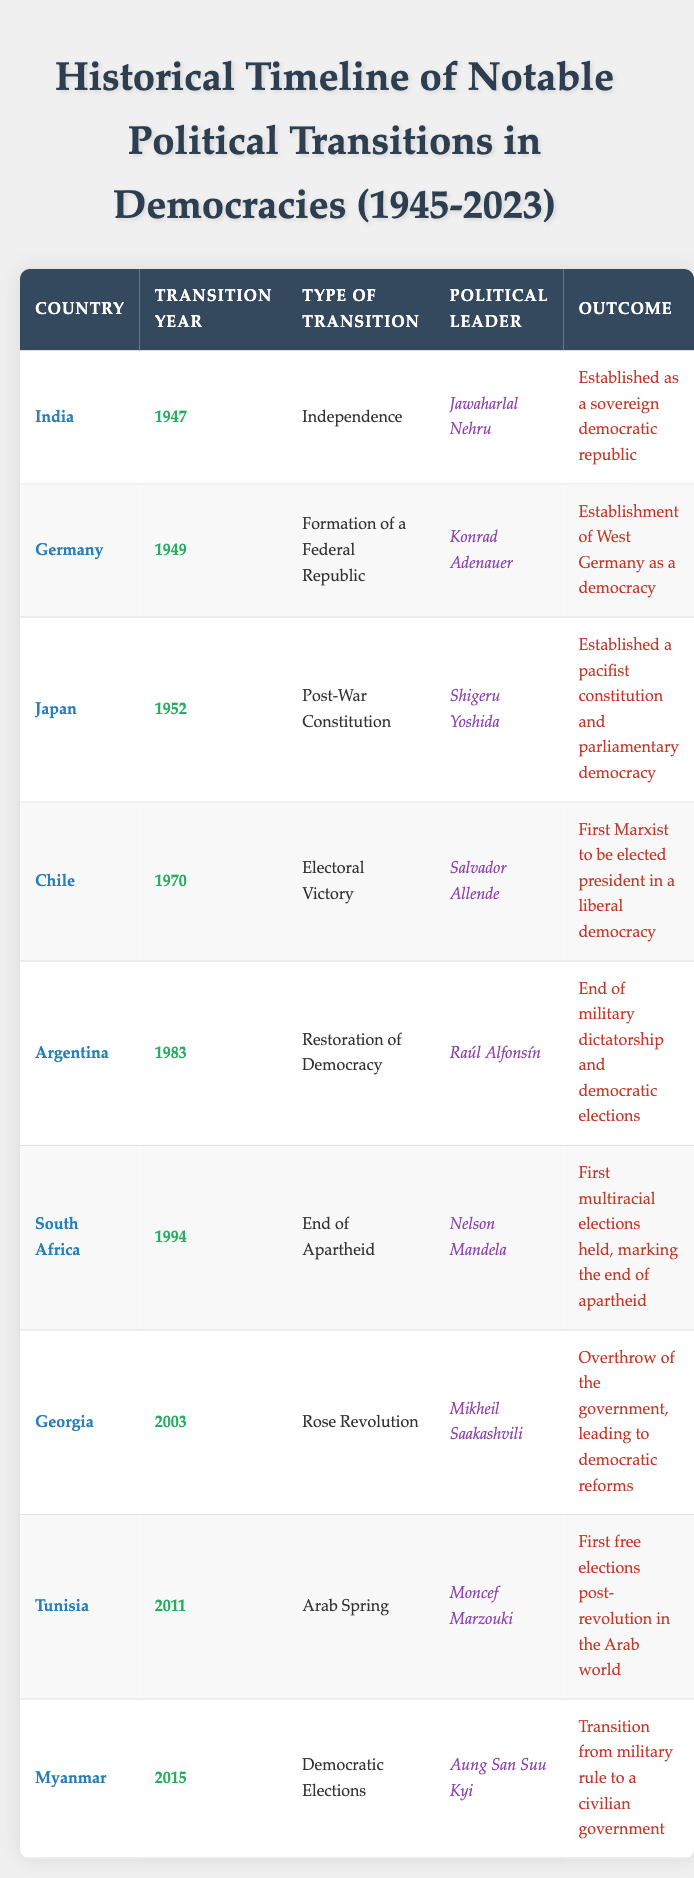What country experienced a transition year in 1983? By looking at the table, we can find the entry for the year 1983 and read the corresponding country. The entry states that Argentina had a transition in 1983.
Answer: Argentina Who was the political leader during Japan's transition in 1952? The table shows that in the row corresponding to Japan in the year 1952, the political leader listed is Shigeru Yoshida.
Answer: Shigeru Yoshida Did South Africa's transition in 1994 lead to a multiracial election? The table indicates that in 1994, South Africa's outcome was described as the first multiracial elections held, which confirms that the statement is true.
Answer: Yes How many transitions occurred between 1950 and 2000? To find this, we count the rows of transitions that fall within the specified range. The entries for 1952 (Japan), 1970 (Chile), 1983 (Argentina), and 1994 (South Africa) give us a total of 4 transitions during this period.
Answer: 4 Was there a political transition in Chile that involved the first Marxist president in a liberal democracy? Reviewing the table shows that in the year 1970 for Chile, the outcome specifies that Salvador Allende was the first Marxist elected as president in a liberal democracy. Therefore, the statement is true.
Answer: Yes What is the outcome of the Rose Revolution in Georgia? In the table, the entry for Georgia in 2003 states the outcome was the overthrow of the government, leading to democratic reforms. This is directly taken from the relevant row.
Answer: Overthrow of the government, leading to democratic reforms Which country achieved independence in 1947? By scanning through the table for the transition year of 1947, we find that the country listed is India.
Answer: India Identify the type of transition that led to the end of apartheid in South Africa. The row for South Africa in 1994 describes the type of transition as the end of apartheid, confirming the specific transition type.
Answer: End of Apartheid 